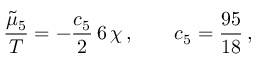<formula> <loc_0><loc_0><loc_500><loc_500>\frac { \tilde { \mu } _ { 5 } } { T } = - \frac { c _ { 5 } } { 2 } \, 6 \, \chi \, , \quad c _ { 5 } = \frac { 9 5 } { 1 8 } \, ,</formula> 